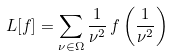Convert formula to latex. <formula><loc_0><loc_0><loc_500><loc_500>L [ f ] = \sum _ { \nu \in \Omega } \frac { 1 } { \nu ^ { 2 } } \, f \left ( \frac { 1 } { \nu ^ { 2 } } \right )</formula> 